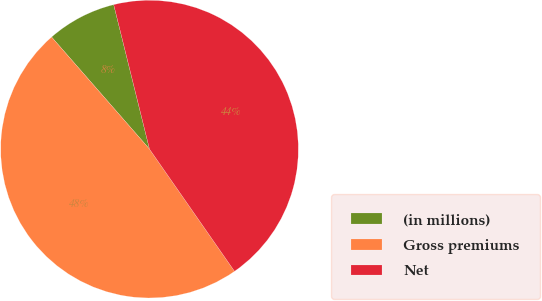Convert chart. <chart><loc_0><loc_0><loc_500><loc_500><pie_chart><fcel>(in millions)<fcel>Gross premiums<fcel>Net<nl><fcel>7.56%<fcel>48.25%<fcel>44.19%<nl></chart> 